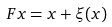Convert formula to latex. <formula><loc_0><loc_0><loc_500><loc_500>F x = x + \xi ( x )</formula> 